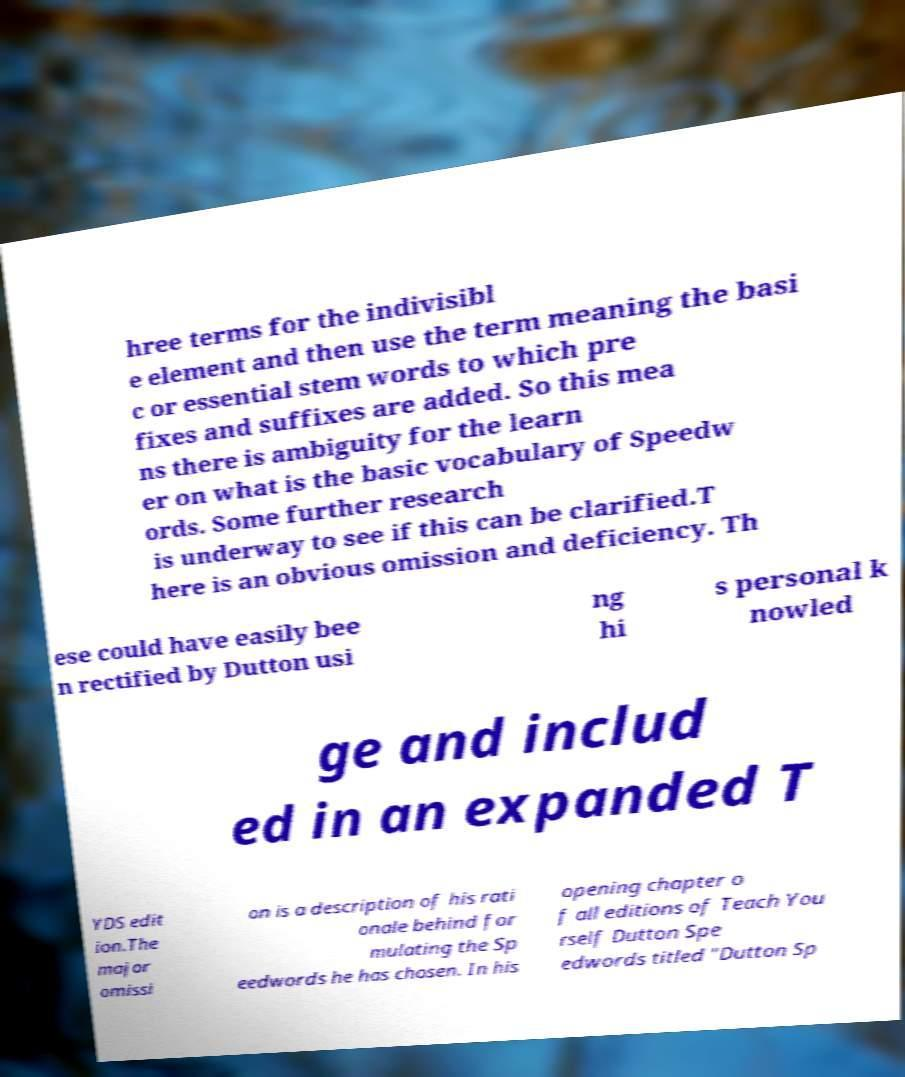For documentation purposes, I need the text within this image transcribed. Could you provide that? hree terms for the indivisibl e element and then use the term meaning the basi c or essential stem words to which pre fixes and suffixes are added. So this mea ns there is ambiguity for the learn er on what is the basic vocabulary of Speedw ords. Some further research is underway to see if this can be clarified.T here is an obvious omission and deficiency. Th ese could have easily bee n rectified by Dutton usi ng hi s personal k nowled ge and includ ed in an expanded T YDS edit ion.The major omissi on is a description of his rati onale behind for mulating the Sp eedwords he has chosen. In his opening chapter o f all editions of Teach You rself Dutton Spe edwords titled "Dutton Sp 